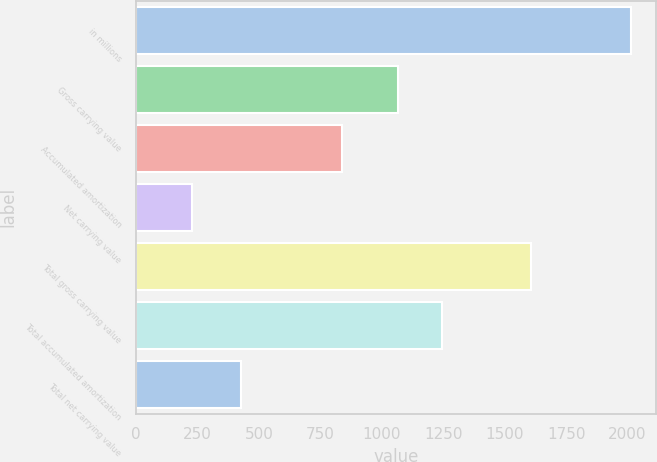<chart> <loc_0><loc_0><loc_500><loc_500><bar_chart><fcel>in millions<fcel>Gross carrying value<fcel>Accumulated amortization<fcel>Net carrying value<fcel>Total gross carrying value<fcel>Total accumulated amortization<fcel>Total net carrying value<nl><fcel>2016<fcel>1065<fcel>837<fcel>228<fcel>1608<fcel>1243.8<fcel>429<nl></chart> 